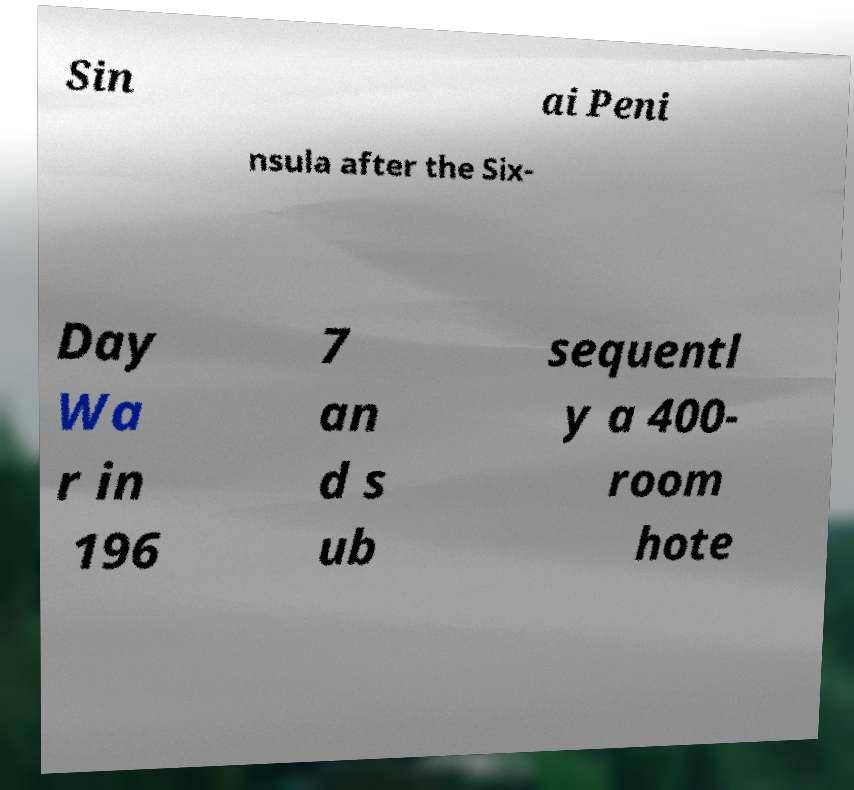I need the written content from this picture converted into text. Can you do that? Sin ai Peni nsula after the Six- Day Wa r in 196 7 an d s ub sequentl y a 400- room hote 